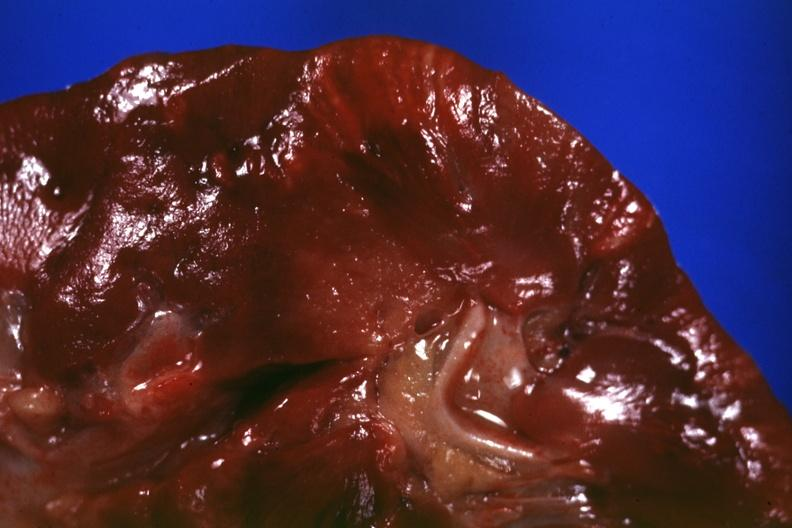what does this image show?
Answer the question using a single word or phrase. Cut surface 